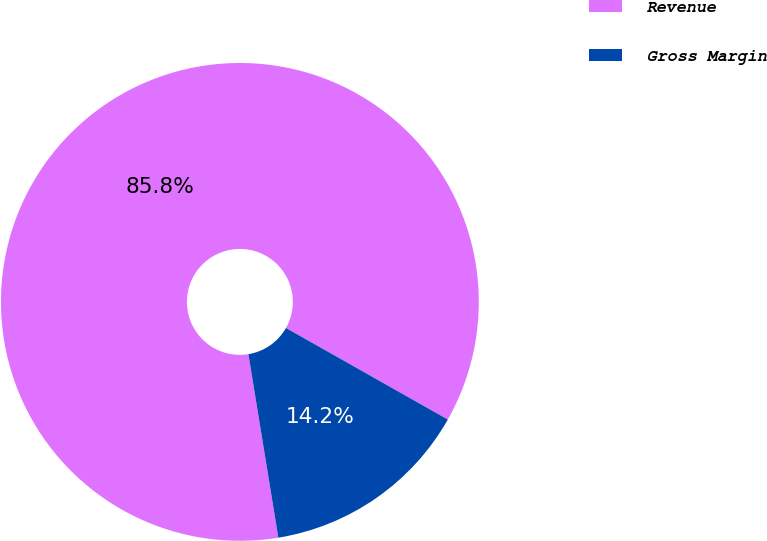Convert chart. <chart><loc_0><loc_0><loc_500><loc_500><pie_chart><fcel>Revenue<fcel>Gross Margin<nl><fcel>85.77%<fcel>14.23%<nl></chart> 